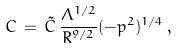<formula> <loc_0><loc_0><loc_500><loc_500>C \, = \, \tilde { C } \, \frac { \Lambda ^ { 1 / 2 } } { R ^ { 9 / 2 } } ( - p ^ { 2 } ) ^ { 1 / 4 } \, ,</formula> 